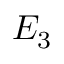<formula> <loc_0><loc_0><loc_500><loc_500>E _ { 3 }</formula> 